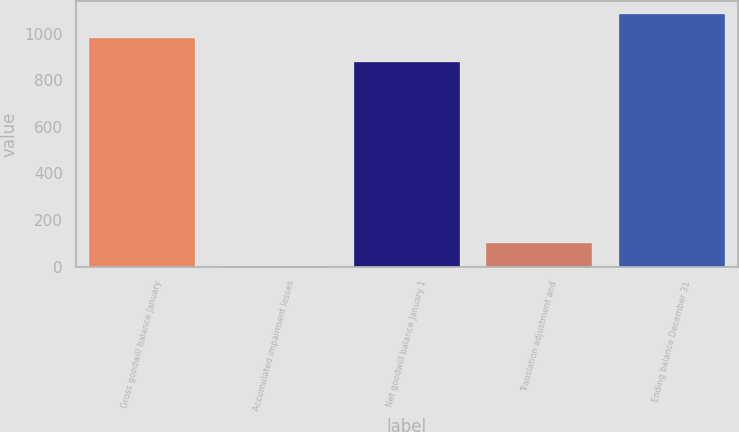Convert chart. <chart><loc_0><loc_0><loc_500><loc_500><bar_chart><fcel>Gross goodwill balance January<fcel>Accumulated impairment losses<fcel>Net goodwill balance January 1<fcel>Translation adjustment and<fcel>Ending balance December 31<nl><fcel>982.38<fcel>0.2<fcel>880<fcel>102.58<fcel>1084.76<nl></chart> 